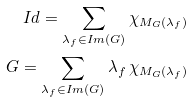<formula> <loc_0><loc_0><loc_500><loc_500>I d = \sum _ { \lambda _ { f } \in I m ( G ) } \chi _ { M _ { G } ( \lambda _ { f } ) } \\ G = \sum _ { \lambda _ { f } \in I m ( G ) } \lambda _ { f } \, \chi _ { M _ { G } ( \lambda _ { f } ) }</formula> 